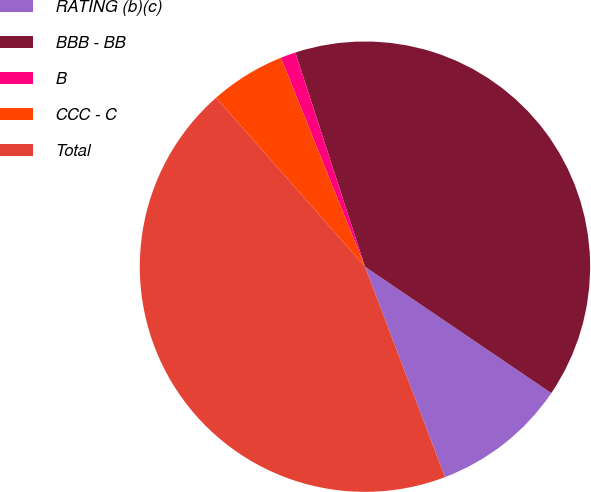Convert chart. <chart><loc_0><loc_0><loc_500><loc_500><pie_chart><fcel>RATING (b)(c)<fcel>BBB - BB<fcel>B<fcel>CCC - C<fcel>Total<nl><fcel>9.73%<fcel>39.49%<fcel>1.09%<fcel>5.41%<fcel>44.29%<nl></chart> 